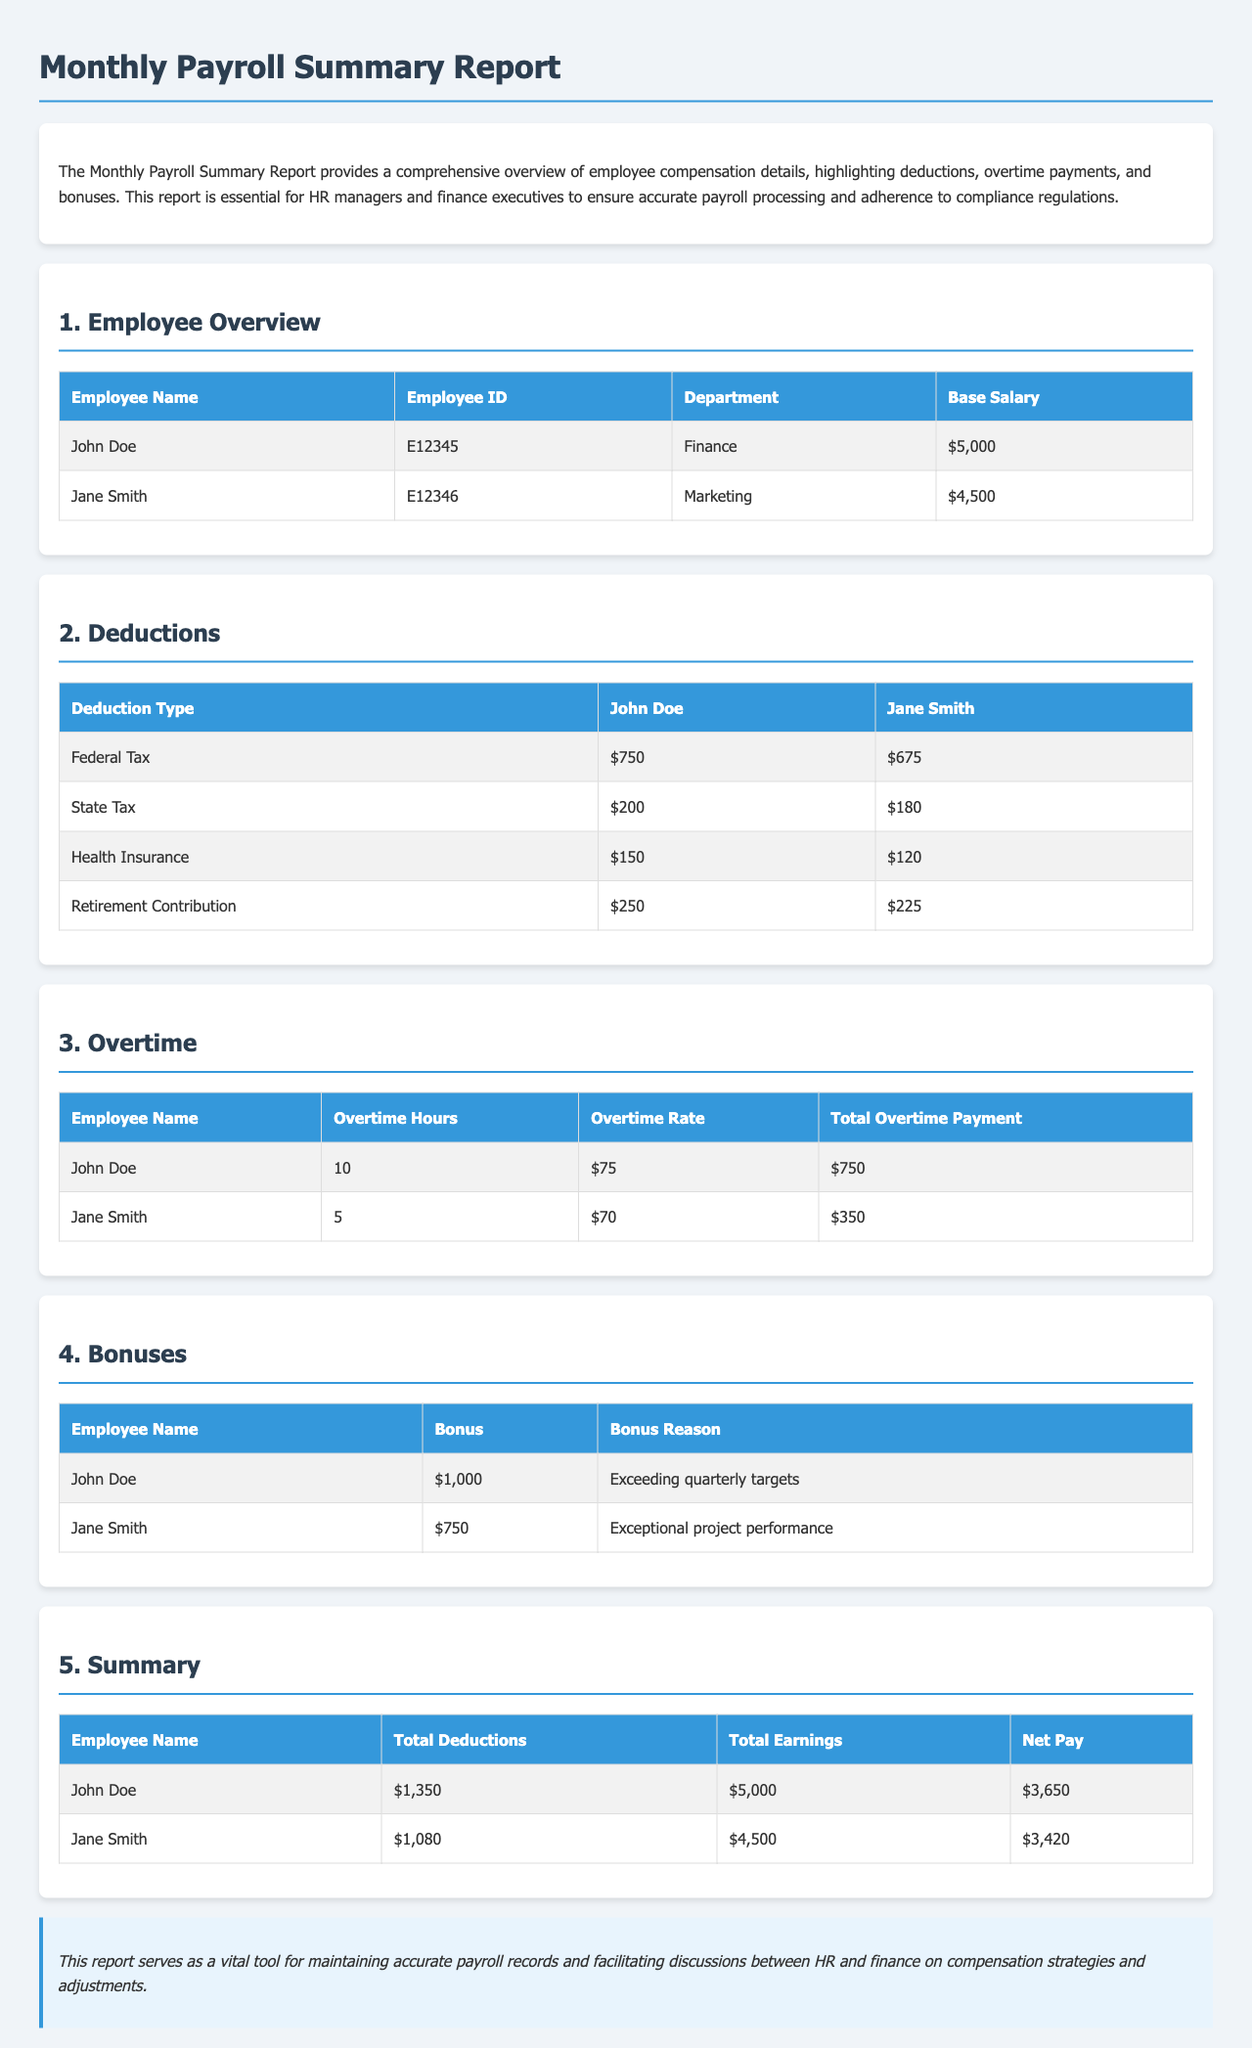What is John Doe's base salary? The base salary for John Doe is provided in the Employee Overview section.
Answer: $5,000 What is the total deduction for Jane Smith? The total deductions for Jane Smith can be found in the Summary section, where all deductions are summed up.
Answer: $1,080 How many overtime hours did Jane Smith work? The Overtime section lists the number of hours worked by Jane Smith.
Answer: 5 What bonus did John Doe receive? The Bonuses section states the bonus amount awarded to John Doe for his performance.
Answer: $1,000 What was the reason for Jane Smith's bonus? The Bonuses section describes the reason behind Jane Smith's bonus payment.
Answer: Exceptional project performance What is the net pay for John Doe? The Summary section provides the net pay amount after deductions for John Doe.
Answer: $3,650 How much was deducted for health insurance from Jane Smith's pay? The Deductions section specifies the amount deducted for health insurance for Jane Smith.
Answer: $120 What is the total overtime payment for John Doe? The Overtime section details the total overtime payment received by John Doe.
Answer: $750 What is the total earnings for Jane Smith? The Summary section summarizes the total earnings for Jane Smith after bonuses and overtime.
Answer: $4,500 